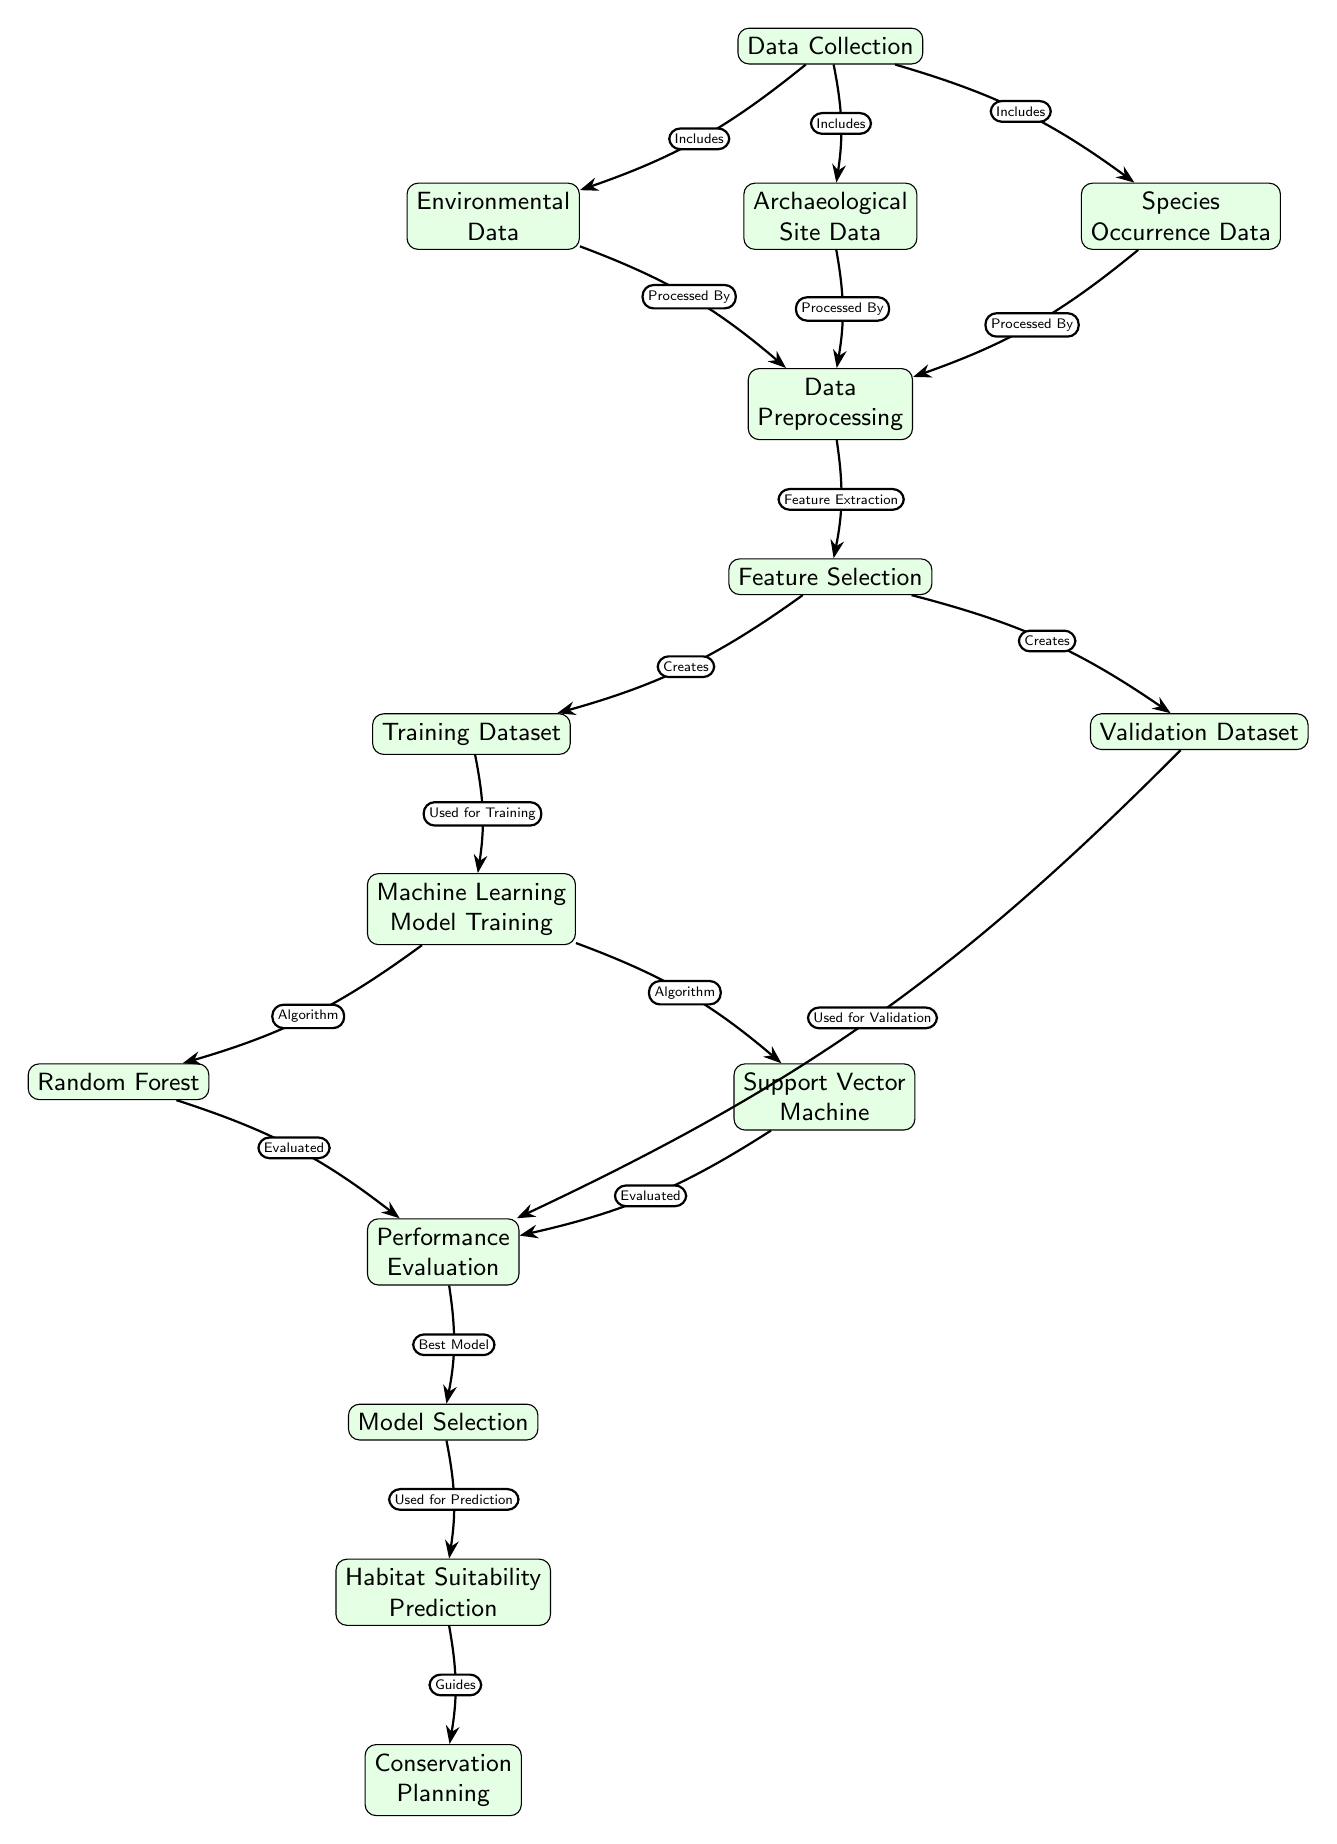What is the first step in the diagram? The first step in the diagram is "Data Collection," which is depicted at the top of the diagram. This node connects to three different data types which are necessary for the modeling process.
Answer: Data Collection How many types of data are included in the "Data Collection" node? The "Data Collection" node consists of three types of data: Environmental Data, Archaeological Site Data, and Species Occurrence Data. These are outlined below the node, indicating the different datasets required for the next steps.
Answer: Three Which node represents the model used for training? The node representing the model used for training is "Machine Learning Model Training," which is connected to both "Random Forest" and "Support Vector Machine" nodes. This indicates that these algorithms are employed for training the model.
Answer: Machine Learning Model Training What is the relationship between "Feature Selection" and "Training Dataset"? "Feature Selection" creates the "Training Dataset," indicating that this process identifies and selects the most relevant features that will be used to train the model effectively. This relationship is crucial for building an accurate predictive model.
Answer: Creates What guides the final step of "Conservation Planning"? The final step, "Conservation Planning," is guided by the "Habitat Suitability Prediction," which is based on the best model selected in the previous steps. Thus, the prediction output directly influences conservation strategies.
Answer: Habitat Suitability Prediction How many machine learning algorithms are evaluated in the diagram? The diagram evaluates two machine learning algorithms: Random Forest and Support Vector Machine, which are both connected to the "Performance Evaluation" node to assess their effectiveness.
Answer: Two What is the main purpose of the "Feature Extraction" in the diagram? The main purpose of "Feature Extraction" is to refine the data collected and prepare it for the next phase of model training, ensuring that only the most relevant features are selected which will improve model performance.
Answer: Refine data What node follows "Performance Evaluation"? "Performance Evaluation" is followed by the "Model Selection" node, which utilizes the evaluation results to determine the best performing model for further predictions about habitat suitability.
Answer: Model Selection 